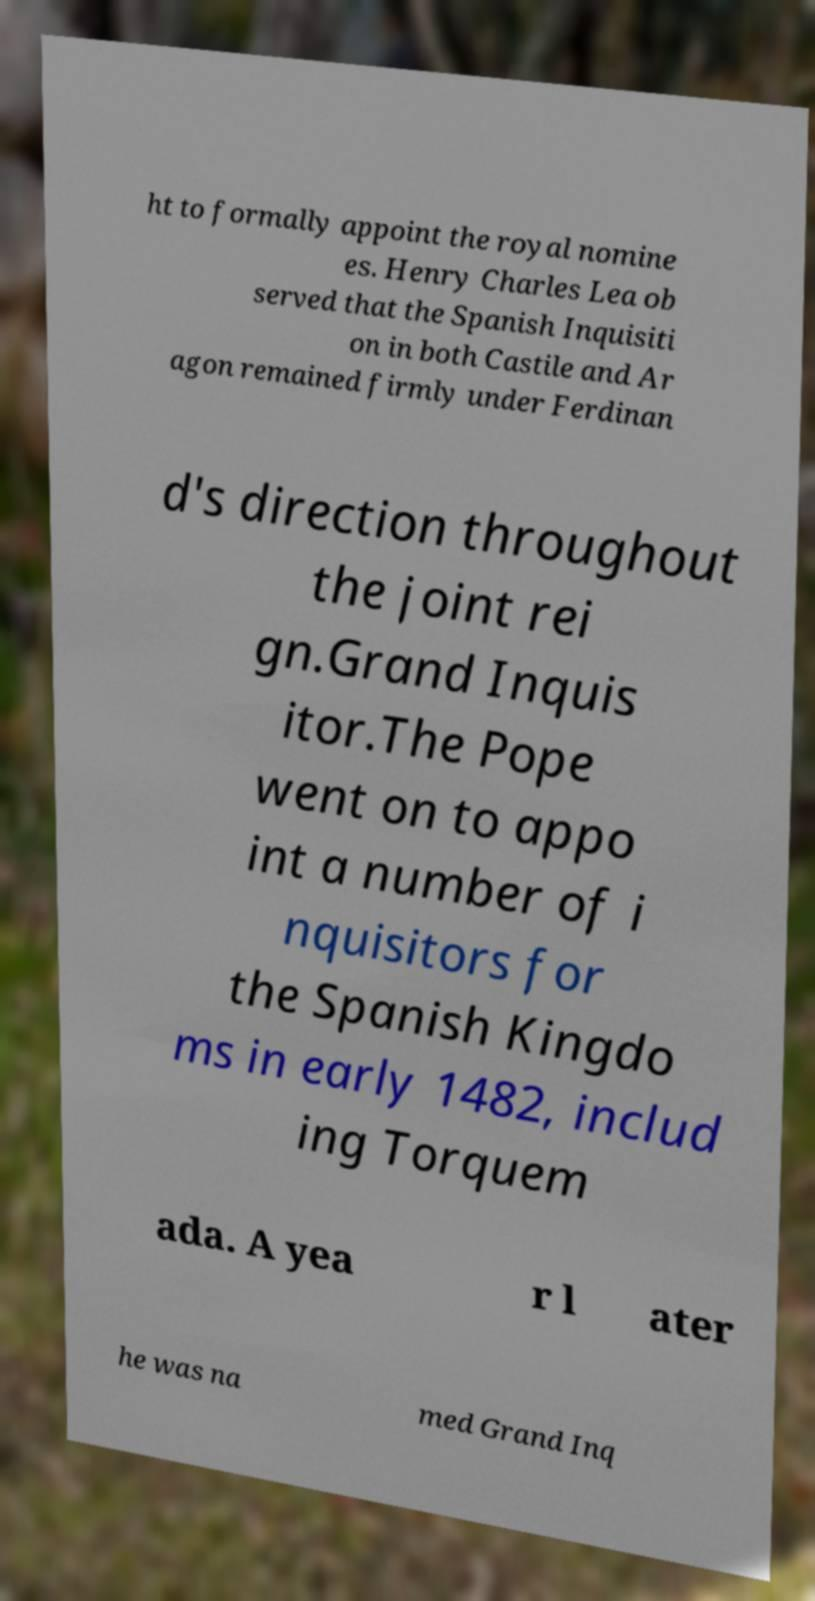What messages or text are displayed in this image? I need them in a readable, typed format. ht to formally appoint the royal nomine es. Henry Charles Lea ob served that the Spanish Inquisiti on in both Castile and Ar agon remained firmly under Ferdinan d's direction throughout the joint rei gn.Grand Inquis itor.The Pope went on to appo int a number of i nquisitors for the Spanish Kingdo ms in early 1482, includ ing Torquem ada. A yea r l ater he was na med Grand Inq 